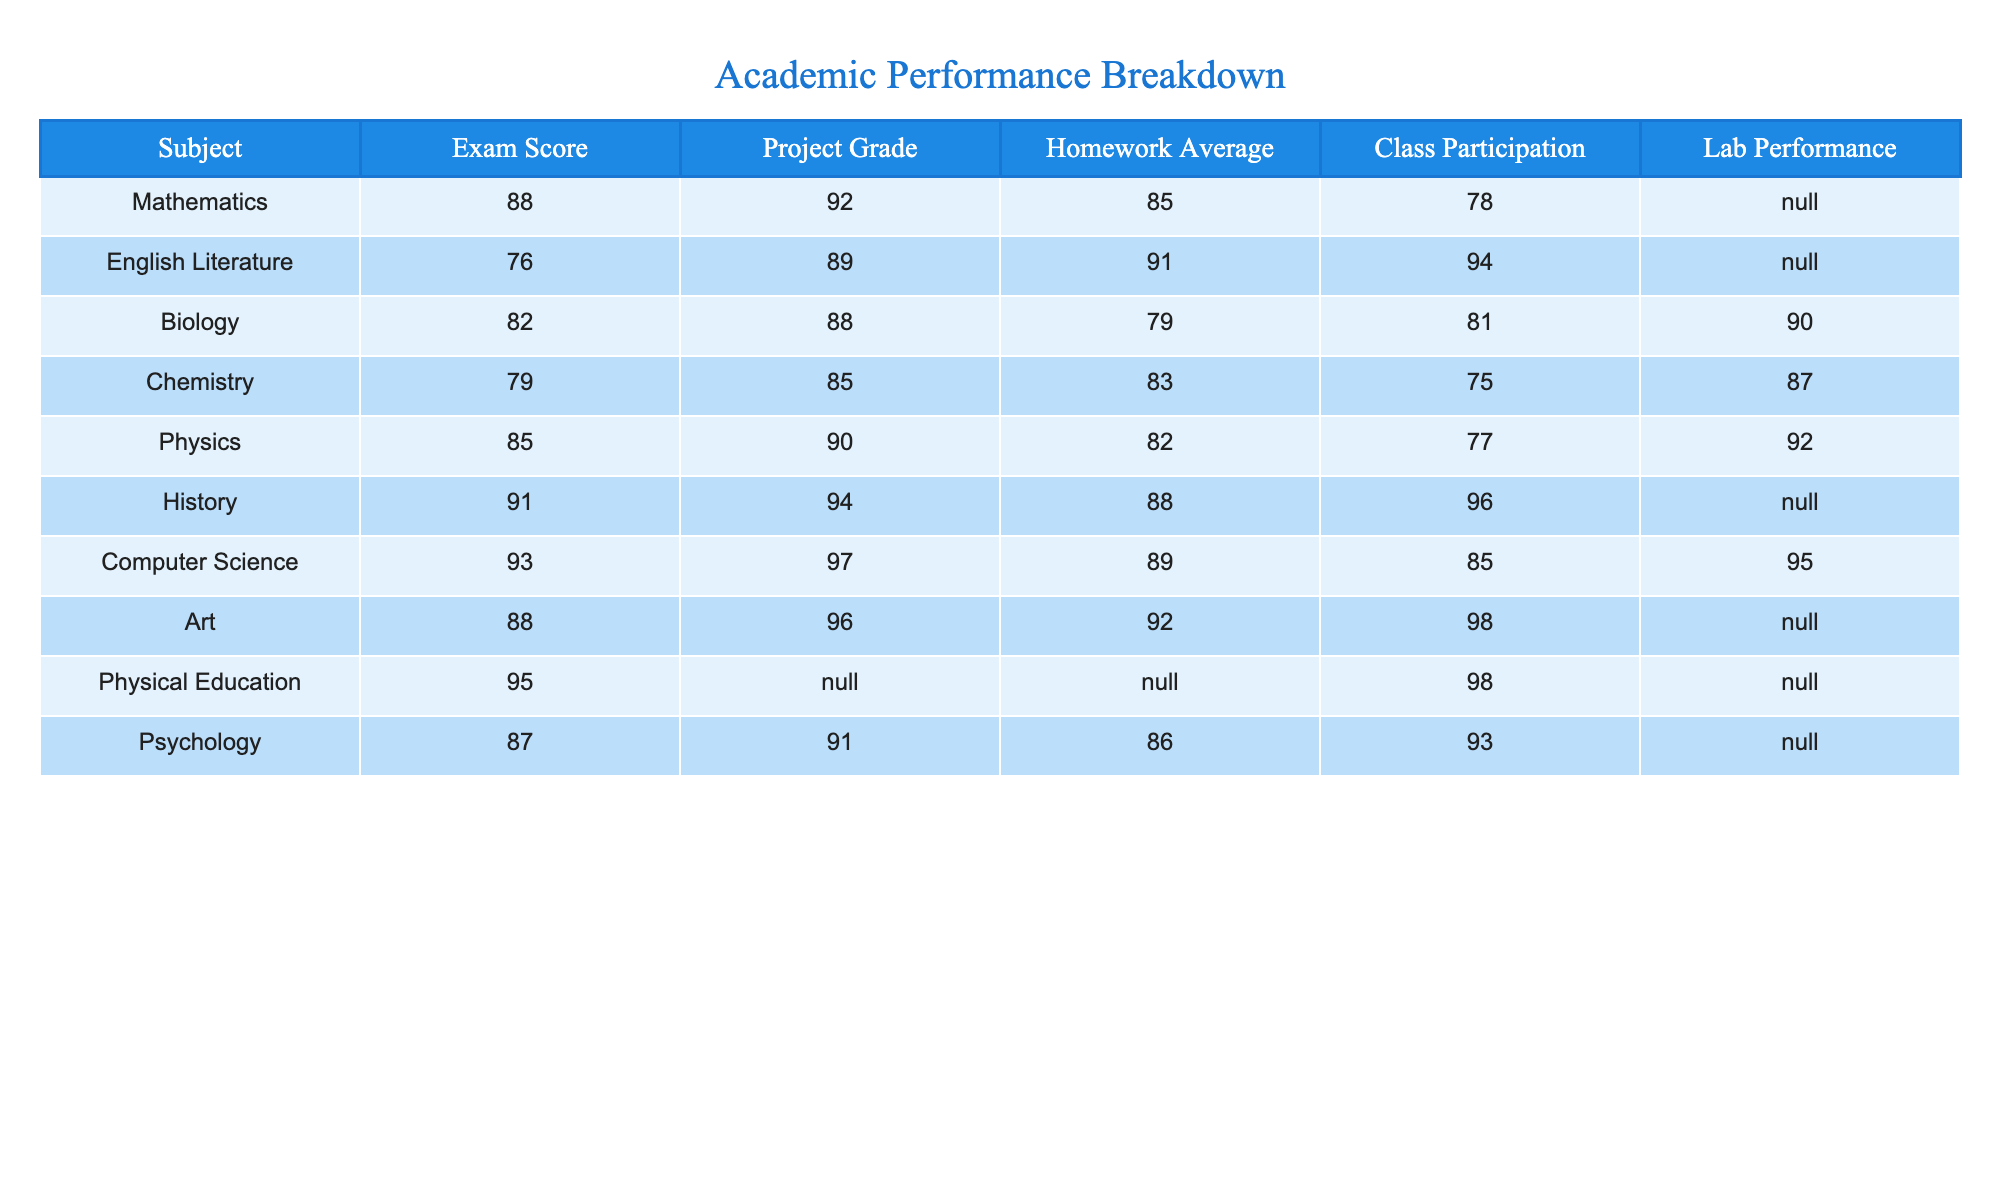What is the highest exam score among all subjects? The table shows exam scores for each subject. By scanning the "Exam Score" column, the highest score found is 95 in Physical Education.
Answer: 95 Which subject has the lowest homework average? The "Homework Average" column indicates the performance across different subjects. The lowest value is 79, which belongs to Biology.
Answer: Biology What is the average project grade for all subjects? To find the average project grade, sum the project grades (92 + 89 + 88 + 85 + 90 + 94 + 97 + 96 + N/A + 91) which equals 926, then divide by the number of subjects with a grade (9 - 1 N/A = 8): 926/8 = 115.75.
Answer: 115.75 Is there a subject with a perfect score in any category? Look through each category for perfect scores (100). There are no entries that indicate a score of 100 for any subject in the given categories.
Answer: No What are the total assignment scores (Exam Score + Project Grade + Homework Average) for Psychology? For Psychology, the values are: Exam Score = 87, Project Grade = 91, Homework Average = 86. Adding these values (87 + 91 + 86) gives a total of 264.
Answer: 264 Which subject has the best lab performance? The "Lab Performance" column shows scores, and the highest score is 92 from Physics.
Answer: Physics How does the average class participation in Humanities subjects compare to Science subjects? The average class participation for Humanities (English Literature, History) is (94 + 96)/2 = 95, and for Science (Biology, Chemistry, Physics) is (81 + 75 + 77)/3 = 77. Compare the two averages: 95 vs 77.
Answer: Humanities is better Which subject has the best overall performance if we consider Exam Score, Project Grade, and Homework Average? Calculate the total score for each subject as follows: Mathematics (88 + 92 + 85), English Literature (76 + 89 + 91), with the highest being Computer Science (93 + 97 + 89 = 279). Comparing totals shows Computer Science has the highest score overall.
Answer: Computer Science How many subjects have N/A values in the Lab Performance category? Scan through the "Lab Performance" column and count the N/A occurrences, which exist in Mathematics, English Literature, History, Art, and Physical Education — totaling 5 subjects.
Answer: 5 What is the difference between the highest and lowest project grades? The highest project grade is 97 (Computer Science) and the lowest is 85 (Chemistry). The difference is calculated as 97 - 85 = 12.
Answer: 12 